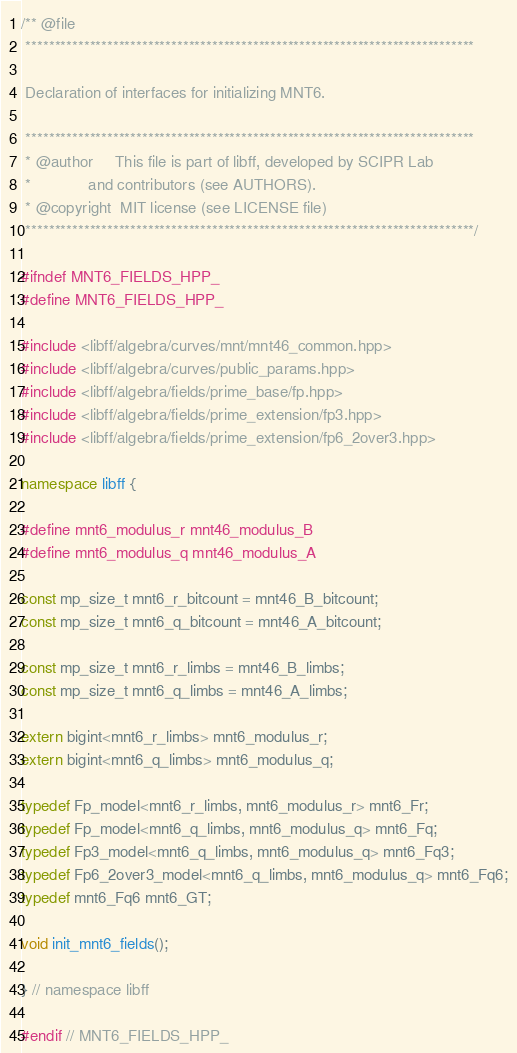Convert code to text. <code><loc_0><loc_0><loc_500><loc_500><_C++_>/** @file
 *****************************************************************************

 Declaration of interfaces for initializing MNT6.

 *****************************************************************************
 * @author     This file is part of libff, developed by SCIPR Lab
 *             and contributors (see AUTHORS).
 * @copyright  MIT license (see LICENSE file)
 *****************************************************************************/

#ifndef MNT6_FIELDS_HPP_
#define MNT6_FIELDS_HPP_

#include <libff/algebra/curves/mnt/mnt46_common.hpp>
#include <libff/algebra/curves/public_params.hpp>
#include <libff/algebra/fields/prime_base/fp.hpp>
#include <libff/algebra/fields/prime_extension/fp3.hpp>
#include <libff/algebra/fields/prime_extension/fp6_2over3.hpp>

namespace libff {

#define mnt6_modulus_r mnt46_modulus_B
#define mnt6_modulus_q mnt46_modulus_A

const mp_size_t mnt6_r_bitcount = mnt46_B_bitcount;
const mp_size_t mnt6_q_bitcount = mnt46_A_bitcount;

const mp_size_t mnt6_r_limbs = mnt46_B_limbs;
const mp_size_t mnt6_q_limbs = mnt46_A_limbs;

extern bigint<mnt6_r_limbs> mnt6_modulus_r;
extern bigint<mnt6_q_limbs> mnt6_modulus_q;

typedef Fp_model<mnt6_r_limbs, mnt6_modulus_r> mnt6_Fr;
typedef Fp_model<mnt6_q_limbs, mnt6_modulus_q> mnt6_Fq;
typedef Fp3_model<mnt6_q_limbs, mnt6_modulus_q> mnt6_Fq3;
typedef Fp6_2over3_model<mnt6_q_limbs, mnt6_modulus_q> mnt6_Fq6;
typedef mnt6_Fq6 mnt6_GT;

void init_mnt6_fields();

} // namespace libff

#endif // MNT6_FIELDS_HPP_
</code> 